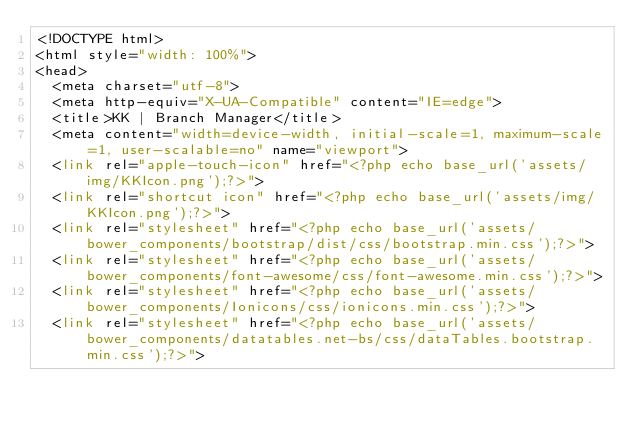<code> <loc_0><loc_0><loc_500><loc_500><_PHP_><!DOCTYPE html>
<html style="width: 100%">
<head>
  <meta charset="utf-8">
  <meta http-equiv="X-UA-Compatible" content="IE=edge">
  <title>KK | Branch Manager</title>
  <meta content="width=device-width, initial-scale=1, maximum-scale=1, user-scalable=no" name="viewport">
  <link rel="apple-touch-icon" href="<?php echo base_url('assets/img/KKIcon.png');?>">
  <link rel="shortcut icon" href="<?php echo base_url('assets/img/KKIcon.png');?>">
  <link rel="stylesheet" href="<?php echo base_url('assets/bower_components/bootstrap/dist/css/bootstrap.min.css');?>">
  <link rel="stylesheet" href="<?php echo base_url('assets/bower_components/font-awesome/css/font-awesome.min.css');?>">
  <link rel="stylesheet" href="<?php echo base_url('assets/bower_components/Ionicons/css/ionicons.min.css');?>">
  <link rel="stylesheet" href="<?php echo base_url('assets/bower_components/datatables.net-bs/css/dataTables.bootstrap.min.css');?>"></code> 